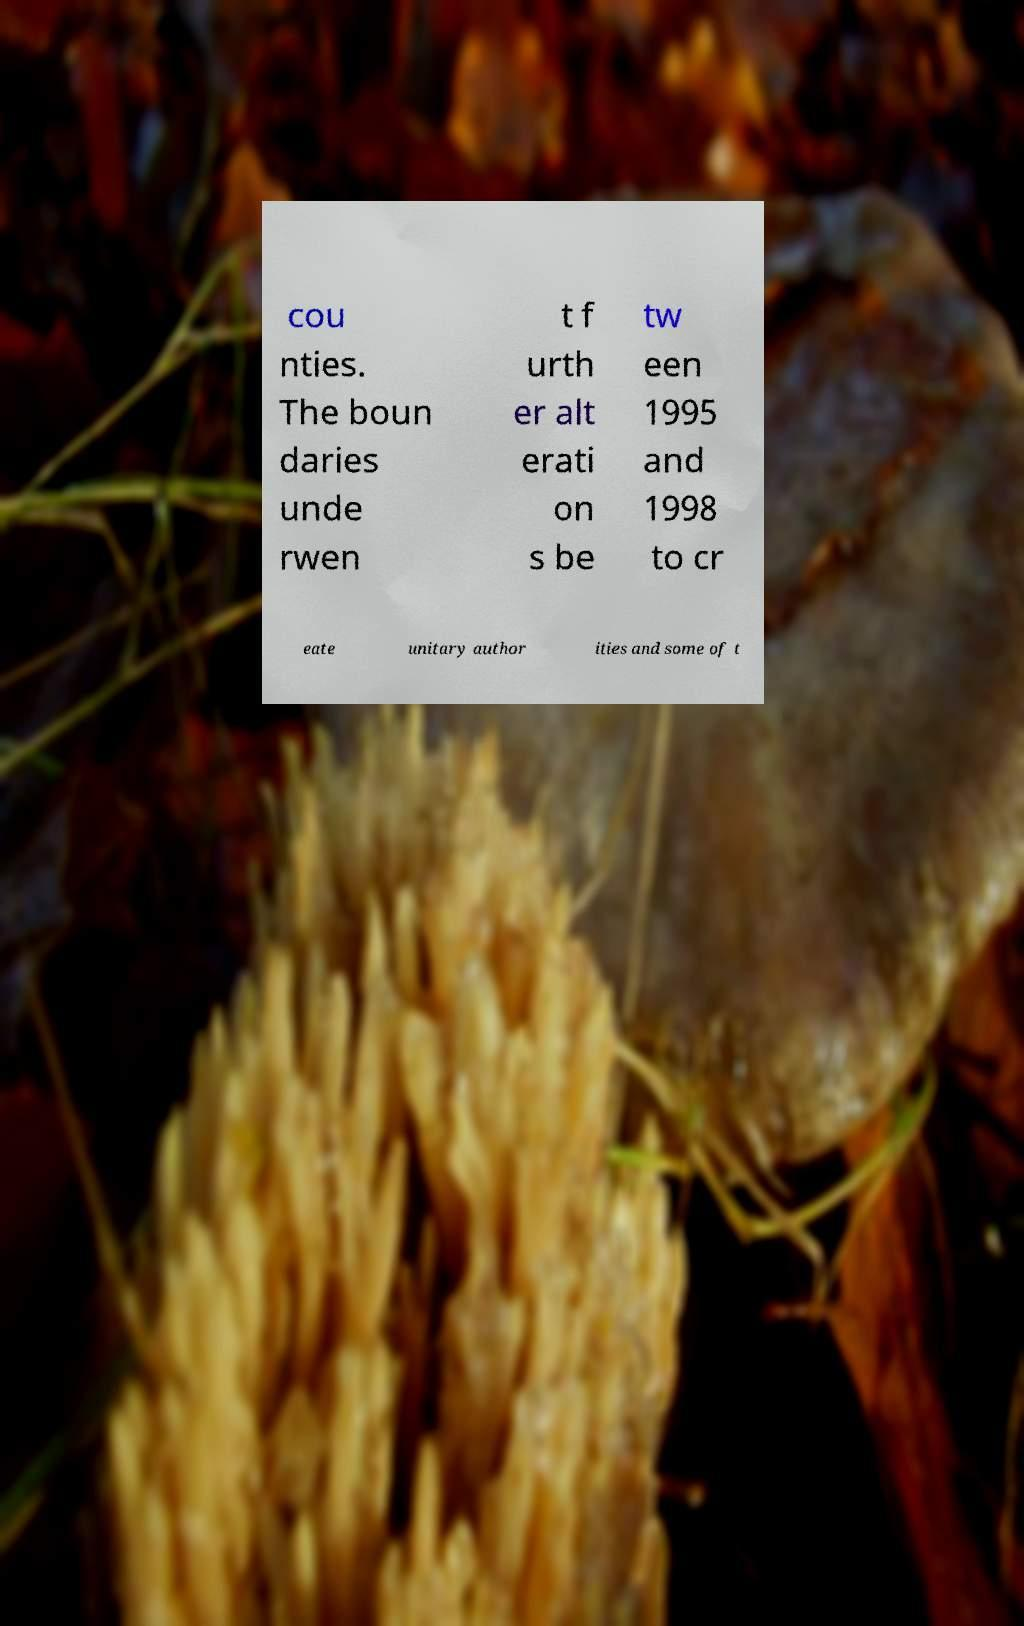For documentation purposes, I need the text within this image transcribed. Could you provide that? cou nties. The boun daries unde rwen t f urth er alt erati on s be tw een 1995 and 1998 to cr eate unitary author ities and some of t 